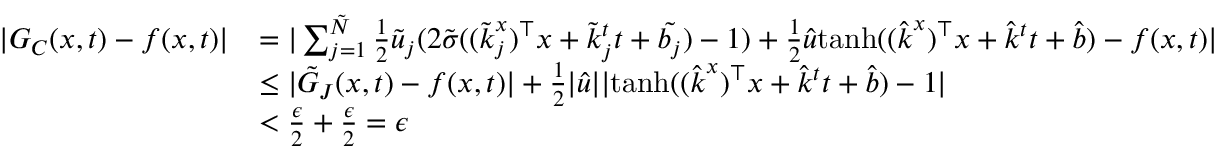<formula> <loc_0><loc_0><loc_500><loc_500>\begin{array} { r l } { | G _ { C } ( x , t ) - f ( x , t ) | } & { = | \sum _ { j = 1 } ^ { \tilde { N } } \frac { 1 } { 2 } \tilde { u } _ { j } ( 2 \tilde { \sigma } ( ( \tilde { k } _ { j } ^ { x } ) ^ { \top } x + \tilde { k } _ { j } ^ { t } t + \tilde { b _ { j } } ) - 1 ) + \frac { 1 } { 2 } \hat { u } t a n h ( ( \hat { k } ^ { x } ) ^ { \top } x + \hat { k } ^ { t } t + \hat { b } ) - f ( x , t ) | } \\ & { \leq | \tilde { G } _ { J } ( x , t ) - f ( x , t ) | + \frac { 1 } { 2 } | \hat { u } | | t a n h ( ( \hat { k } ^ { x } ) ^ { \top } x + \hat { k } ^ { t } t + \hat { b } ) - 1 | } \\ & { < \frac { \epsilon } { 2 } + \frac { \epsilon } { 2 } = \epsilon } \end{array}</formula> 